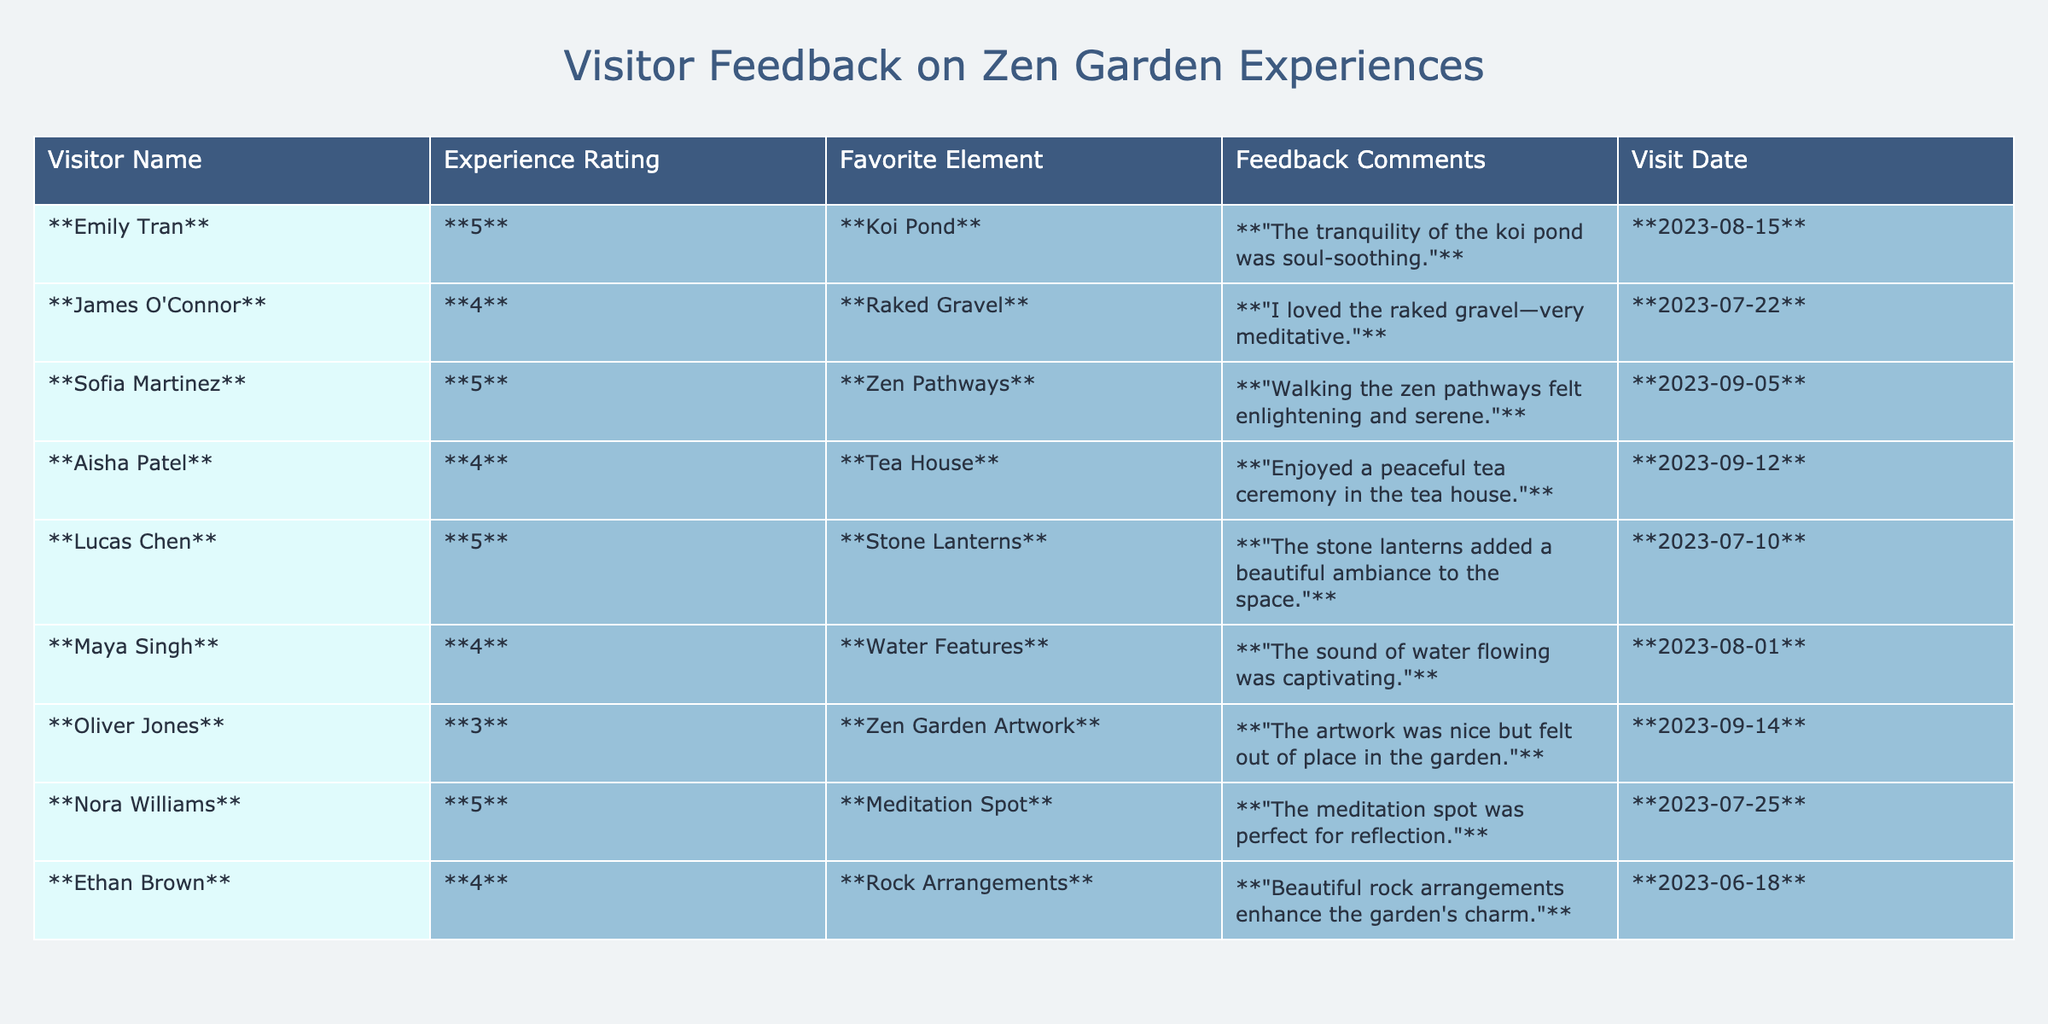What is the highest experience rating given by a visitor? The highest experience rating in the table is **5**, which is noted next to several visitors (Emily Tran, Sofia Martinez, Lucas Chen, and Nora Williams).
Answer: 5 Which favorite element received the most positive feedback? The favorite elements with a rating of **5** are Koi Pond, Zen Pathways, Stone Lanterns, and Meditation Spot, indicating strong positive feedback for all these elements.
Answer: Koi Pond, Zen Pathways, Stone Lanterns, and Meditation Spot What was the visit date of the visitor with the lowest experience rating? The visitor with the lowest rating of **3** is Oliver Jones, who visited on **September 14, 2023**.
Answer: September 14, 2023 How many visitors rated the Zen garden experience as 4? There are **4** visitors who rated their experience as **4** (James O'Connor, Aisha Patel, Maya Singh, and Ethan Brown).
Answer: 4 Is there any visitor who rated their experience as 3? Yes, there is one visitor, Oliver Jones, who rated his experience as **3**.
Answer: Yes What is the average experience rating based on the feedback provided? The experience ratings are 5, 4, 5, 4, 5, 4, 3, 5, 4, which sum to **43**. There are 10 ratings in total, therefore the average is 43 / 10 = **4.3**.
Answer: 4.3 Which favorite element appears most frequently among the highest ratings? The elements with a rating of **5** are Koi Pond, Zen Pathways, Stone Lanterns, and Meditation Spot. Therefore, all of these elements appear frequently among the highest ratings (4 occurrences).
Answer: Koi Pond, Zen Pathways, Stone Lanterns, Meditation Spot What feedback did Aisha Patel provide about her experience? Aisha Patel provided the feedback: "Enjoyed a peaceful tea ceremony in the tea house." which reflects a positive experience.
Answer: "Enjoyed a peaceful tea ceremony in the tea house." Did any visitor mention a negative aspect of their experience? Yes, Oliver Jones mentioned the artwork felt "out of place in the garden," indicating a negative aspect of his experience.
Answer: Yes How many visitors expressed enjoyment of the water features? **1** visitor (Maya Singh) expressed enjoyment of the water features, rating it **4** and stating, "The sound of water flowing was captivating."
Answer: 1 